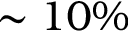Convert formula to latex. <formula><loc_0><loc_0><loc_500><loc_500>\sim 1 0 \%</formula> 